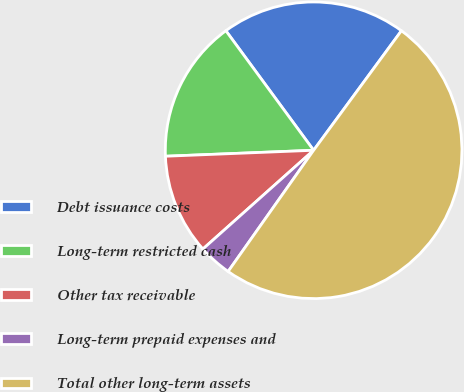Convert chart. <chart><loc_0><loc_0><loc_500><loc_500><pie_chart><fcel>Debt issuance costs<fcel>Long-term restricted cash<fcel>Other tax receivable<fcel>Long-term prepaid expenses and<fcel>Total other long-term assets<nl><fcel>20.16%<fcel>15.56%<fcel>10.95%<fcel>3.63%<fcel>49.69%<nl></chart> 